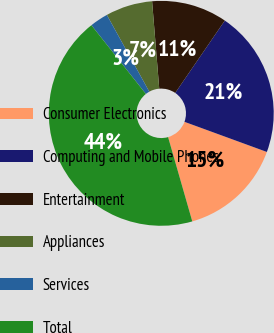<chart> <loc_0><loc_0><loc_500><loc_500><pie_chart><fcel>Consumer Electronics<fcel>Computing and Mobile Phones<fcel>Entertainment<fcel>Appliances<fcel>Services<fcel>Total<nl><fcel>14.97%<fcel>21.02%<fcel>10.86%<fcel>6.74%<fcel>2.63%<fcel>43.78%<nl></chart> 